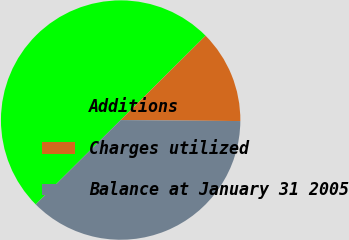<chart> <loc_0><loc_0><loc_500><loc_500><pie_chart><fcel>Additions<fcel>Charges utilized<fcel>Balance at January 31 2005<nl><fcel>50.0%<fcel>12.58%<fcel>37.42%<nl></chart> 